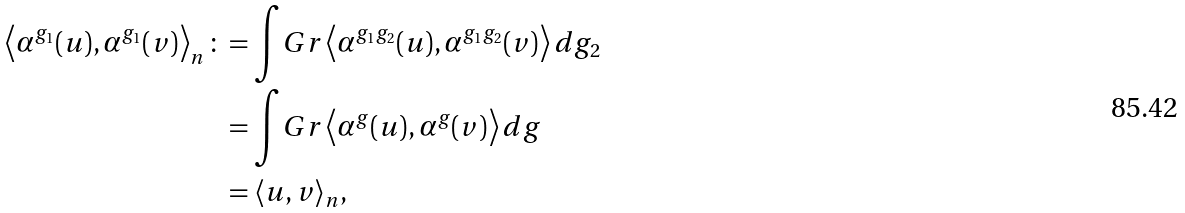<formula> <loc_0><loc_0><loc_500><loc_500>\left \langle \alpha ^ { g _ { 1 } } ( u ) , \alpha ^ { g _ { 1 } } ( v ) \right \rangle _ { n } \colon & = \int _ { \ } G r \left \langle \alpha ^ { g _ { 1 } g _ { 2 } } ( u ) , \alpha ^ { g _ { 1 } g _ { 2 } } ( v ) \right \rangle d g _ { 2 } \\ & = \int _ { \ } G r \left \langle \alpha ^ { g } ( u ) , \alpha ^ { g } ( v ) \right \rangle d g \\ & = \langle u , v \rangle _ { n } ,</formula> 